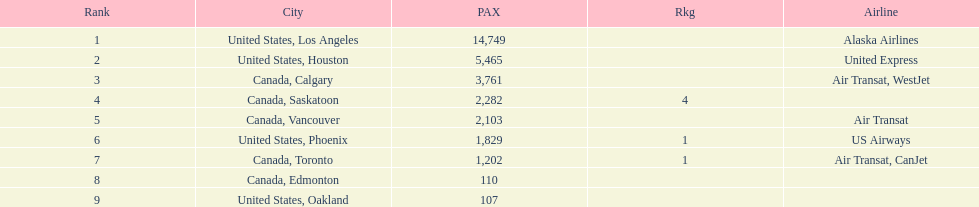The least number of passengers came from which city United States, Oakland. Would you be able to parse every entry in this table? {'header': ['Rank', 'City', 'PAX', 'Rkg', 'Airline'], 'rows': [['1', 'United States, Los Angeles', '14,749', '', 'Alaska Airlines'], ['2', 'United States, Houston', '5,465', '', 'United Express'], ['3', 'Canada, Calgary', '3,761', '', 'Air Transat, WestJet'], ['4', 'Canada, Saskatoon', '2,282', '4', ''], ['5', 'Canada, Vancouver', '2,103', '', 'Air Transat'], ['6', 'United States, Phoenix', '1,829', '1', 'US Airways'], ['7', 'Canada, Toronto', '1,202', '1', 'Air Transat, CanJet'], ['8', 'Canada, Edmonton', '110', '', ''], ['9', 'United States, Oakland', '107', '', '']]} 